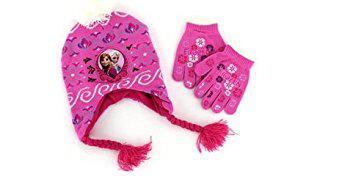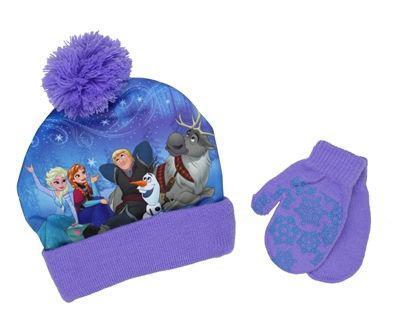The first image is the image on the left, the second image is the image on the right. Given the left and right images, does the statement "One image shows a pair of mittens, not gloves, next to a blue cap with a pom-pom ball on top." hold true? Answer yes or no. Yes. 